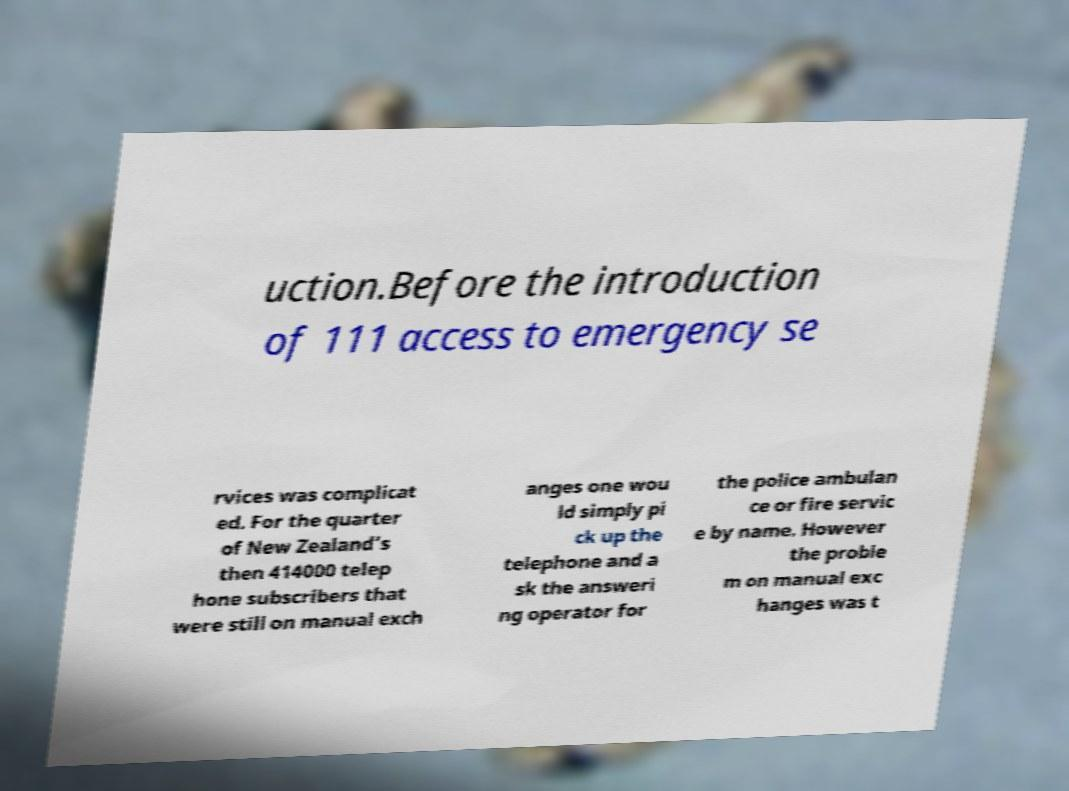Please identify and transcribe the text found in this image. uction.Before the introduction of 111 access to emergency se rvices was complicat ed. For the quarter of New Zealand’s then 414000 telep hone subscribers that were still on manual exch anges one wou ld simply pi ck up the telephone and a sk the answeri ng operator for the police ambulan ce or fire servic e by name. However the proble m on manual exc hanges was t 